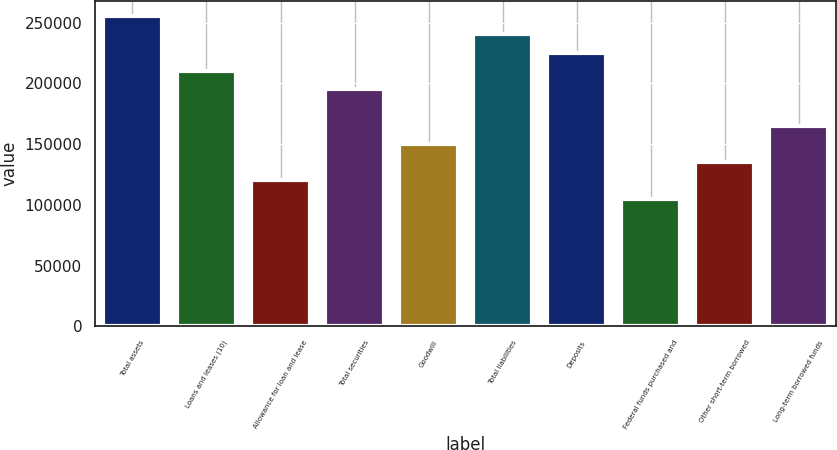Convert chart to OTSL. <chart><loc_0><loc_0><loc_500><loc_500><bar_chart><fcel>Total assets<fcel>Loans and leases (10)<fcel>Allowance for loan and lease<fcel>Total securities<fcel>Goodwill<fcel>Total liabilities<fcel>Deposits<fcel>Federal funds purchased and<fcel>Other short-term borrowed<fcel>Long-term borrowed funds<nl><fcel>255484<fcel>210399<fcel>120228<fcel>195370<fcel>150285<fcel>240455<fcel>225427<fcel>105200<fcel>135257<fcel>165313<nl></chart> 